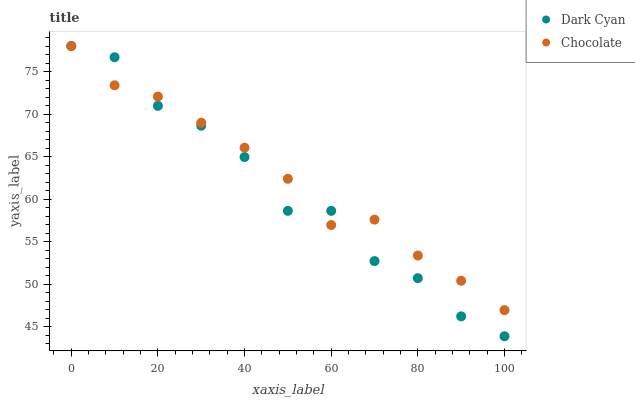Does Dark Cyan have the minimum area under the curve?
Answer yes or no. Yes. Does Chocolate have the maximum area under the curve?
Answer yes or no. Yes. Does Chocolate have the minimum area under the curve?
Answer yes or no. No. Is Chocolate the smoothest?
Answer yes or no. Yes. Is Dark Cyan the roughest?
Answer yes or no. Yes. Is Chocolate the roughest?
Answer yes or no. No. Does Dark Cyan have the lowest value?
Answer yes or no. Yes. Does Chocolate have the lowest value?
Answer yes or no. No. Does Chocolate have the highest value?
Answer yes or no. Yes. Does Chocolate intersect Dark Cyan?
Answer yes or no. Yes. Is Chocolate less than Dark Cyan?
Answer yes or no. No. Is Chocolate greater than Dark Cyan?
Answer yes or no. No. 